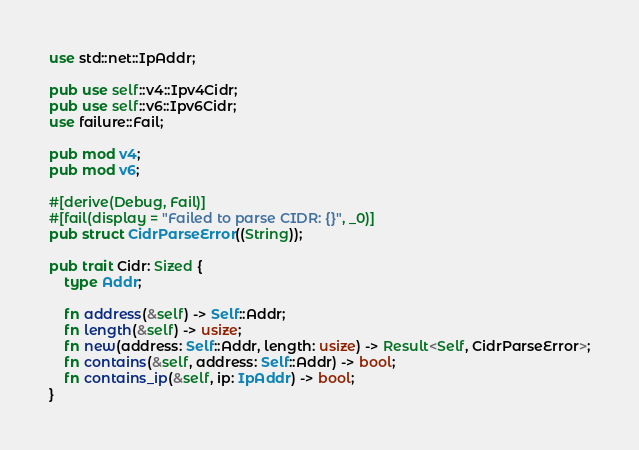Convert code to text. <code><loc_0><loc_0><loc_500><loc_500><_Rust_>use std::net::IpAddr;

pub use self::v4::Ipv4Cidr;
pub use self::v6::Ipv6Cidr;
use failure::Fail;

pub mod v4;
pub mod v6;

#[derive(Debug, Fail)]
#[fail(display = "Failed to parse CIDR: {}", _0)]
pub struct CidrParseError((String));

pub trait Cidr: Sized {
    type Addr;

    fn address(&self) -> Self::Addr;
    fn length(&self) -> usize;
    fn new(address: Self::Addr, length: usize) -> Result<Self, CidrParseError>;
    fn contains(&self, address: Self::Addr) -> bool;
    fn contains_ip(&self, ip: IpAddr) -> bool;
}
</code> 